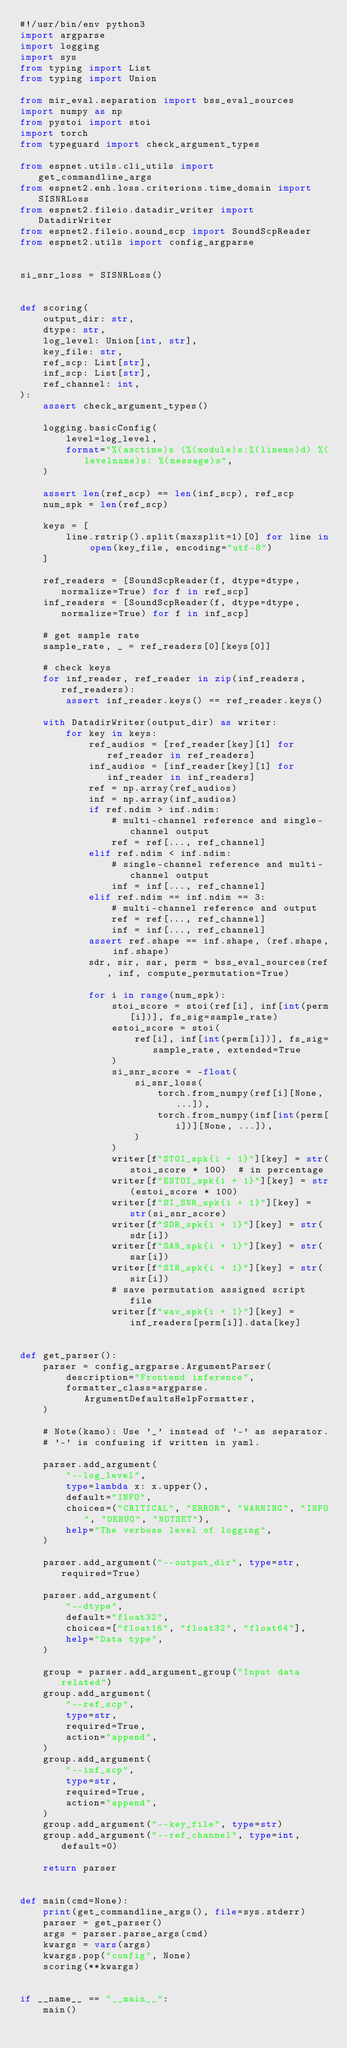Convert code to text. <code><loc_0><loc_0><loc_500><loc_500><_Python_>#!/usr/bin/env python3
import argparse
import logging
import sys
from typing import List
from typing import Union

from mir_eval.separation import bss_eval_sources
import numpy as np
from pystoi import stoi
import torch
from typeguard import check_argument_types

from espnet.utils.cli_utils import get_commandline_args
from espnet2.enh.loss.criterions.time_domain import SISNRLoss
from espnet2.fileio.datadir_writer import DatadirWriter
from espnet2.fileio.sound_scp import SoundScpReader
from espnet2.utils import config_argparse


si_snr_loss = SISNRLoss()


def scoring(
    output_dir: str,
    dtype: str,
    log_level: Union[int, str],
    key_file: str,
    ref_scp: List[str],
    inf_scp: List[str],
    ref_channel: int,
):
    assert check_argument_types()

    logging.basicConfig(
        level=log_level,
        format="%(asctime)s (%(module)s:%(lineno)d) %(levelname)s: %(message)s",
    )

    assert len(ref_scp) == len(inf_scp), ref_scp
    num_spk = len(ref_scp)

    keys = [
        line.rstrip().split(maxsplit=1)[0] for line in open(key_file, encoding="utf-8")
    ]

    ref_readers = [SoundScpReader(f, dtype=dtype, normalize=True) for f in ref_scp]
    inf_readers = [SoundScpReader(f, dtype=dtype, normalize=True) for f in inf_scp]

    # get sample rate
    sample_rate, _ = ref_readers[0][keys[0]]

    # check keys
    for inf_reader, ref_reader in zip(inf_readers, ref_readers):
        assert inf_reader.keys() == ref_reader.keys()

    with DatadirWriter(output_dir) as writer:
        for key in keys:
            ref_audios = [ref_reader[key][1] for ref_reader in ref_readers]
            inf_audios = [inf_reader[key][1] for inf_reader in inf_readers]
            ref = np.array(ref_audios)
            inf = np.array(inf_audios)
            if ref.ndim > inf.ndim:
                # multi-channel reference and single-channel output
                ref = ref[..., ref_channel]
            elif ref.ndim < inf.ndim:
                # single-channel reference and multi-channel output
                inf = inf[..., ref_channel]
            elif ref.ndim == inf.ndim == 3:
                # multi-channel reference and output
                ref = ref[..., ref_channel]
                inf = inf[..., ref_channel]
            assert ref.shape == inf.shape, (ref.shape, inf.shape)
            sdr, sir, sar, perm = bss_eval_sources(ref, inf, compute_permutation=True)

            for i in range(num_spk):
                stoi_score = stoi(ref[i], inf[int(perm[i])], fs_sig=sample_rate)
                estoi_score = stoi(
                    ref[i], inf[int(perm[i])], fs_sig=sample_rate, extended=True
                )
                si_snr_score = -float(
                    si_snr_loss(
                        torch.from_numpy(ref[i][None, ...]),
                        torch.from_numpy(inf[int(perm[i])][None, ...]),
                    )
                )
                writer[f"STOI_spk{i + 1}"][key] = str(stoi_score * 100)  # in percentage
                writer[f"ESTOI_spk{i + 1}"][key] = str(estoi_score * 100)
                writer[f"SI_SNR_spk{i + 1}"][key] = str(si_snr_score)
                writer[f"SDR_spk{i + 1}"][key] = str(sdr[i])
                writer[f"SAR_spk{i + 1}"][key] = str(sar[i])
                writer[f"SIR_spk{i + 1}"][key] = str(sir[i])
                # save permutation assigned script file
                writer[f"wav_spk{i + 1}"][key] = inf_readers[perm[i]].data[key]


def get_parser():
    parser = config_argparse.ArgumentParser(
        description="Frontend inference",
        formatter_class=argparse.ArgumentDefaultsHelpFormatter,
    )

    # Note(kamo): Use '_' instead of '-' as separator.
    # '-' is confusing if written in yaml.

    parser.add_argument(
        "--log_level",
        type=lambda x: x.upper(),
        default="INFO",
        choices=("CRITICAL", "ERROR", "WARNING", "INFO", "DEBUG", "NOTSET"),
        help="The verbose level of logging",
    )

    parser.add_argument("--output_dir", type=str, required=True)

    parser.add_argument(
        "--dtype",
        default="float32",
        choices=["float16", "float32", "float64"],
        help="Data type",
    )

    group = parser.add_argument_group("Input data related")
    group.add_argument(
        "--ref_scp",
        type=str,
        required=True,
        action="append",
    )
    group.add_argument(
        "--inf_scp",
        type=str,
        required=True,
        action="append",
    )
    group.add_argument("--key_file", type=str)
    group.add_argument("--ref_channel", type=int, default=0)

    return parser


def main(cmd=None):
    print(get_commandline_args(), file=sys.stderr)
    parser = get_parser()
    args = parser.parse_args(cmd)
    kwargs = vars(args)
    kwargs.pop("config", None)
    scoring(**kwargs)


if __name__ == "__main__":
    main()
</code> 